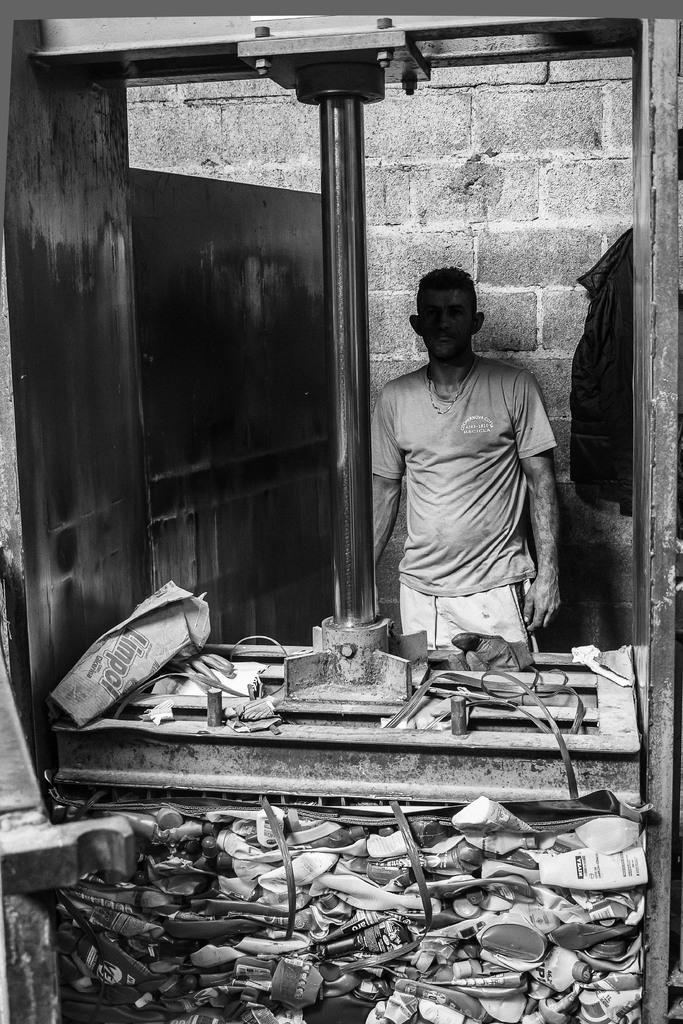What is the color scheme of the image? The image is black and white. Who or what is present in the image? There is a man in the image. Where is the man positioned in the image? The man is standing in front of a wall. What can be seen below the wall in the image? There is a machine with footwear below it in the image. How many bears are sitting on the machine with footwear in the image? There are no bears present in the image; it features a man standing in front of a wall with a machine and footwear below it. 